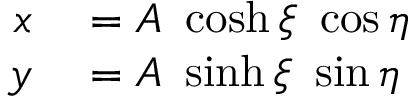Convert formula to latex. <formula><loc_0><loc_0><loc_500><loc_500>\begin{array} { r l } { x } & = A \ \cosh \xi \ \cos \eta } \\ { y } & = A \ \sinh \xi \ \sin \eta } \end{array}</formula> 